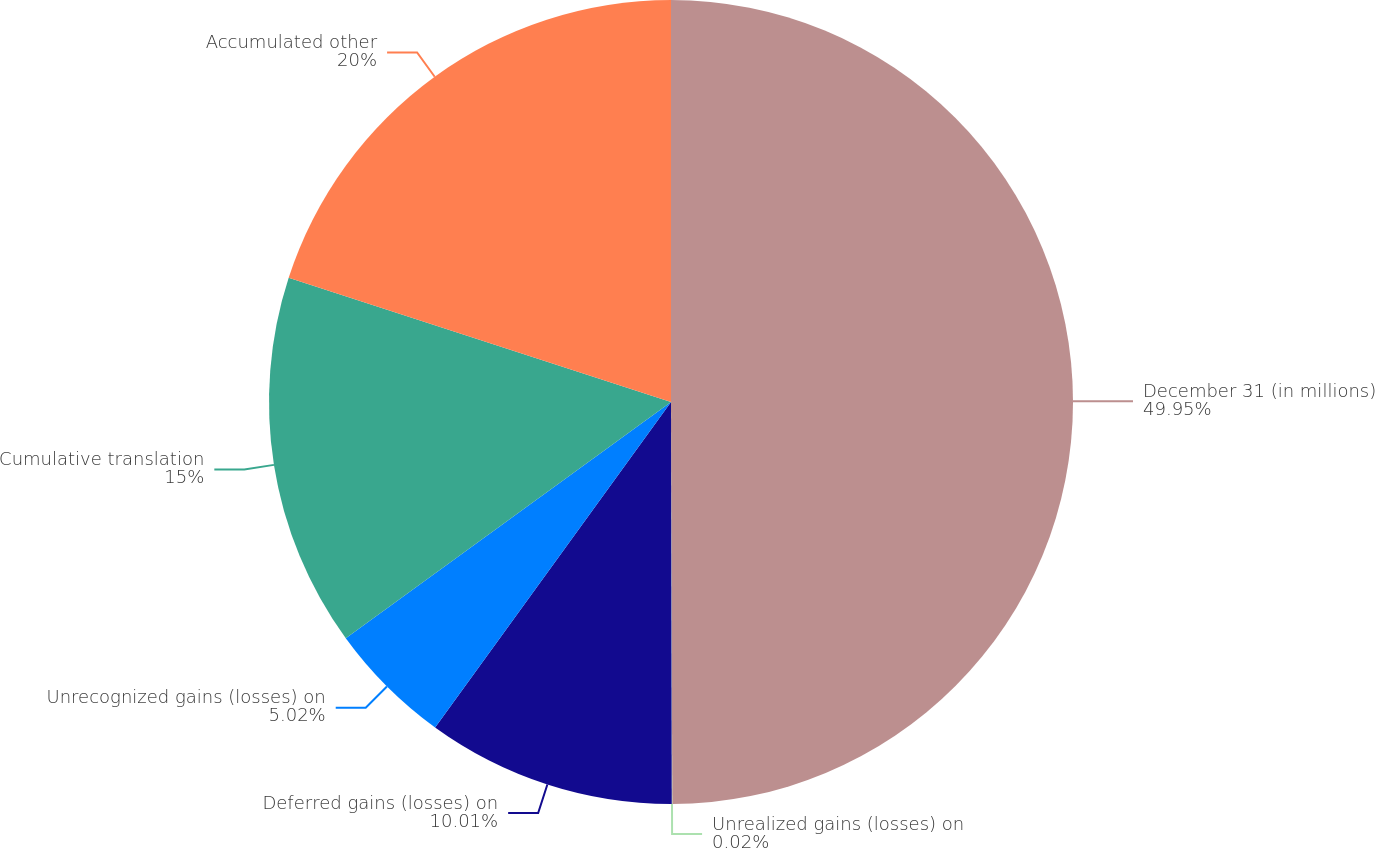<chart> <loc_0><loc_0><loc_500><loc_500><pie_chart><fcel>December 31 (in millions)<fcel>Unrealized gains (losses) on<fcel>Deferred gains (losses) on<fcel>Unrecognized gains (losses) on<fcel>Cumulative translation<fcel>Accumulated other<nl><fcel>49.95%<fcel>0.02%<fcel>10.01%<fcel>5.02%<fcel>15.0%<fcel>20.0%<nl></chart> 